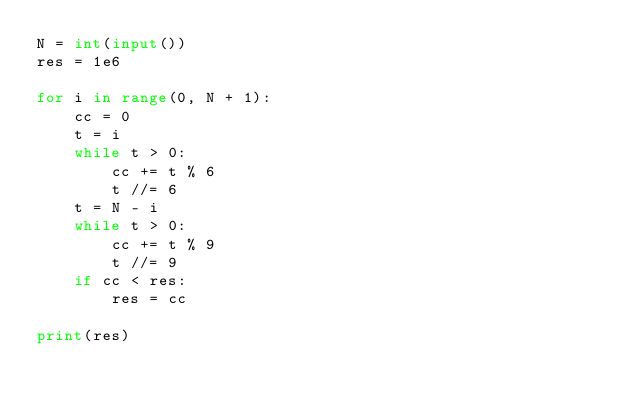<code> <loc_0><loc_0><loc_500><loc_500><_Python_>N = int(input())
res = 1e6

for i in range(0, N + 1):
    cc = 0
    t = i
    while t > 0:
        cc += t % 6
        t //= 6
    t = N - i
    while t > 0:
        cc += t % 9
        t //= 9
    if cc < res:
        res = cc

print(res)
</code> 